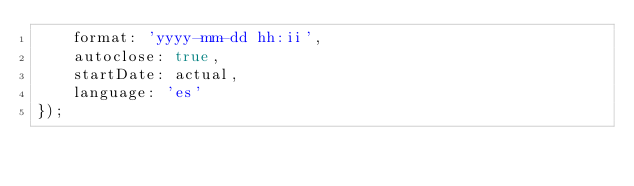<code> <loc_0><loc_0><loc_500><loc_500><_JavaScript_>    format: 'yyyy-mm-dd hh:ii',
    autoclose: true,
    startDate: actual,
    language: 'es'
});
</code> 